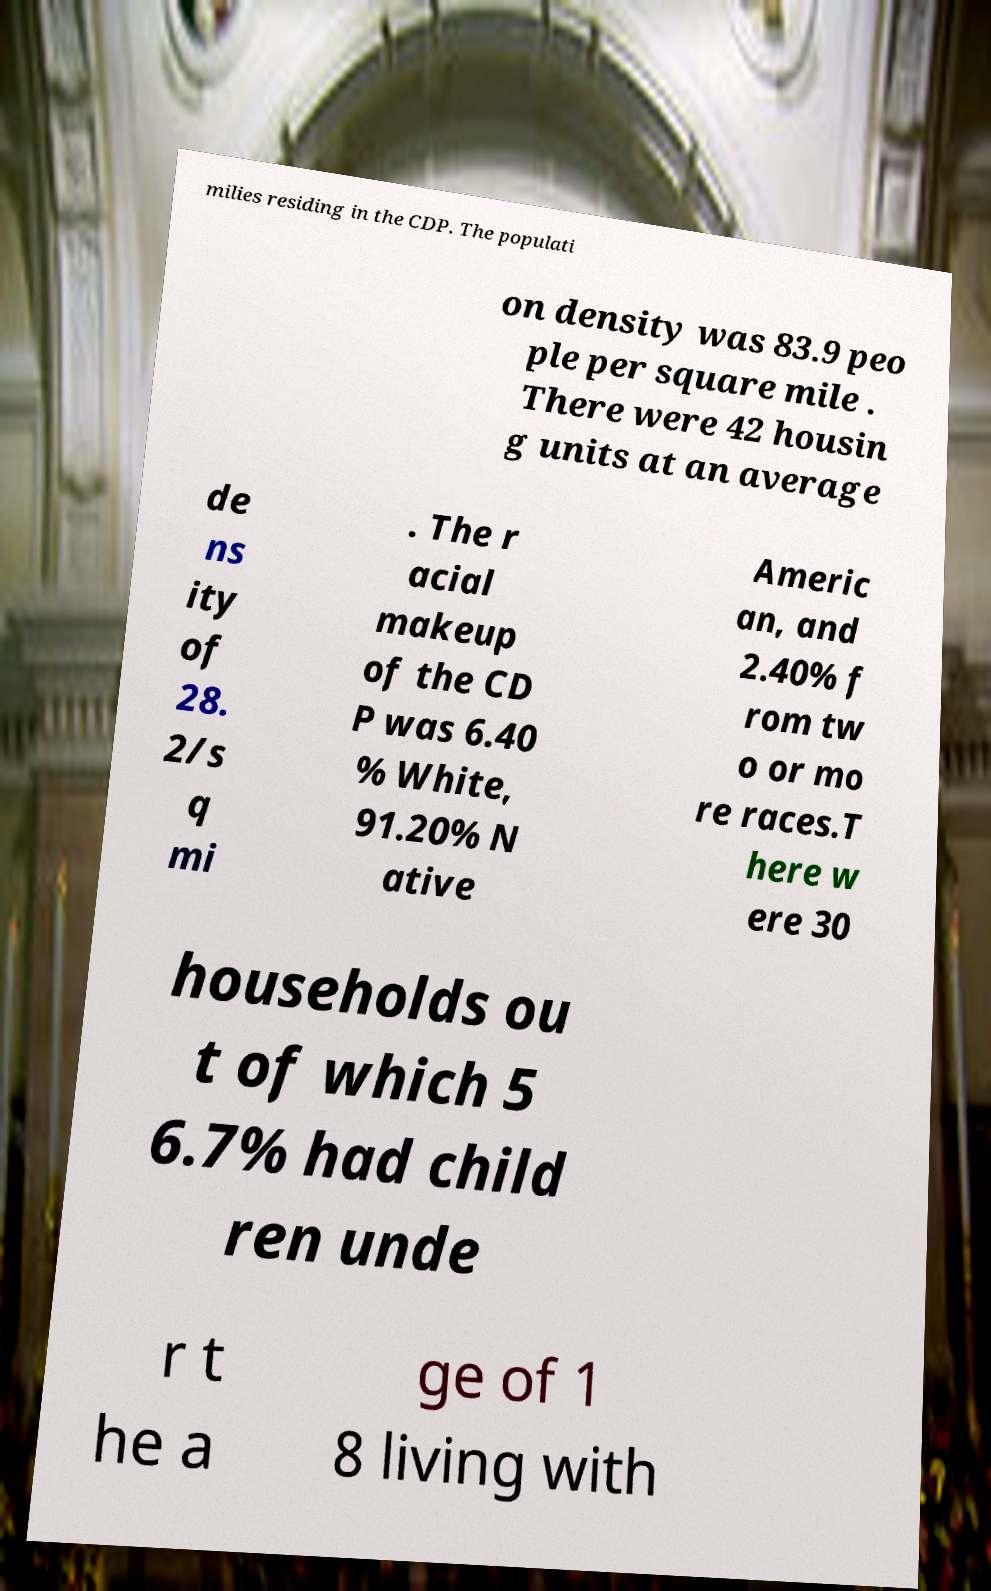I need the written content from this picture converted into text. Can you do that? milies residing in the CDP. The populati on density was 83.9 peo ple per square mile . There were 42 housin g units at an average de ns ity of 28. 2/s q mi . The r acial makeup of the CD P was 6.40 % White, 91.20% N ative Americ an, and 2.40% f rom tw o or mo re races.T here w ere 30 households ou t of which 5 6.7% had child ren unde r t he a ge of 1 8 living with 